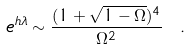Convert formula to latex. <formula><loc_0><loc_0><loc_500><loc_500>e ^ { h \lambda } \sim \frac { ( 1 + \sqrt { 1 - \Omega } ) ^ { 4 } } { \Omega ^ { 2 } } \ .</formula> 